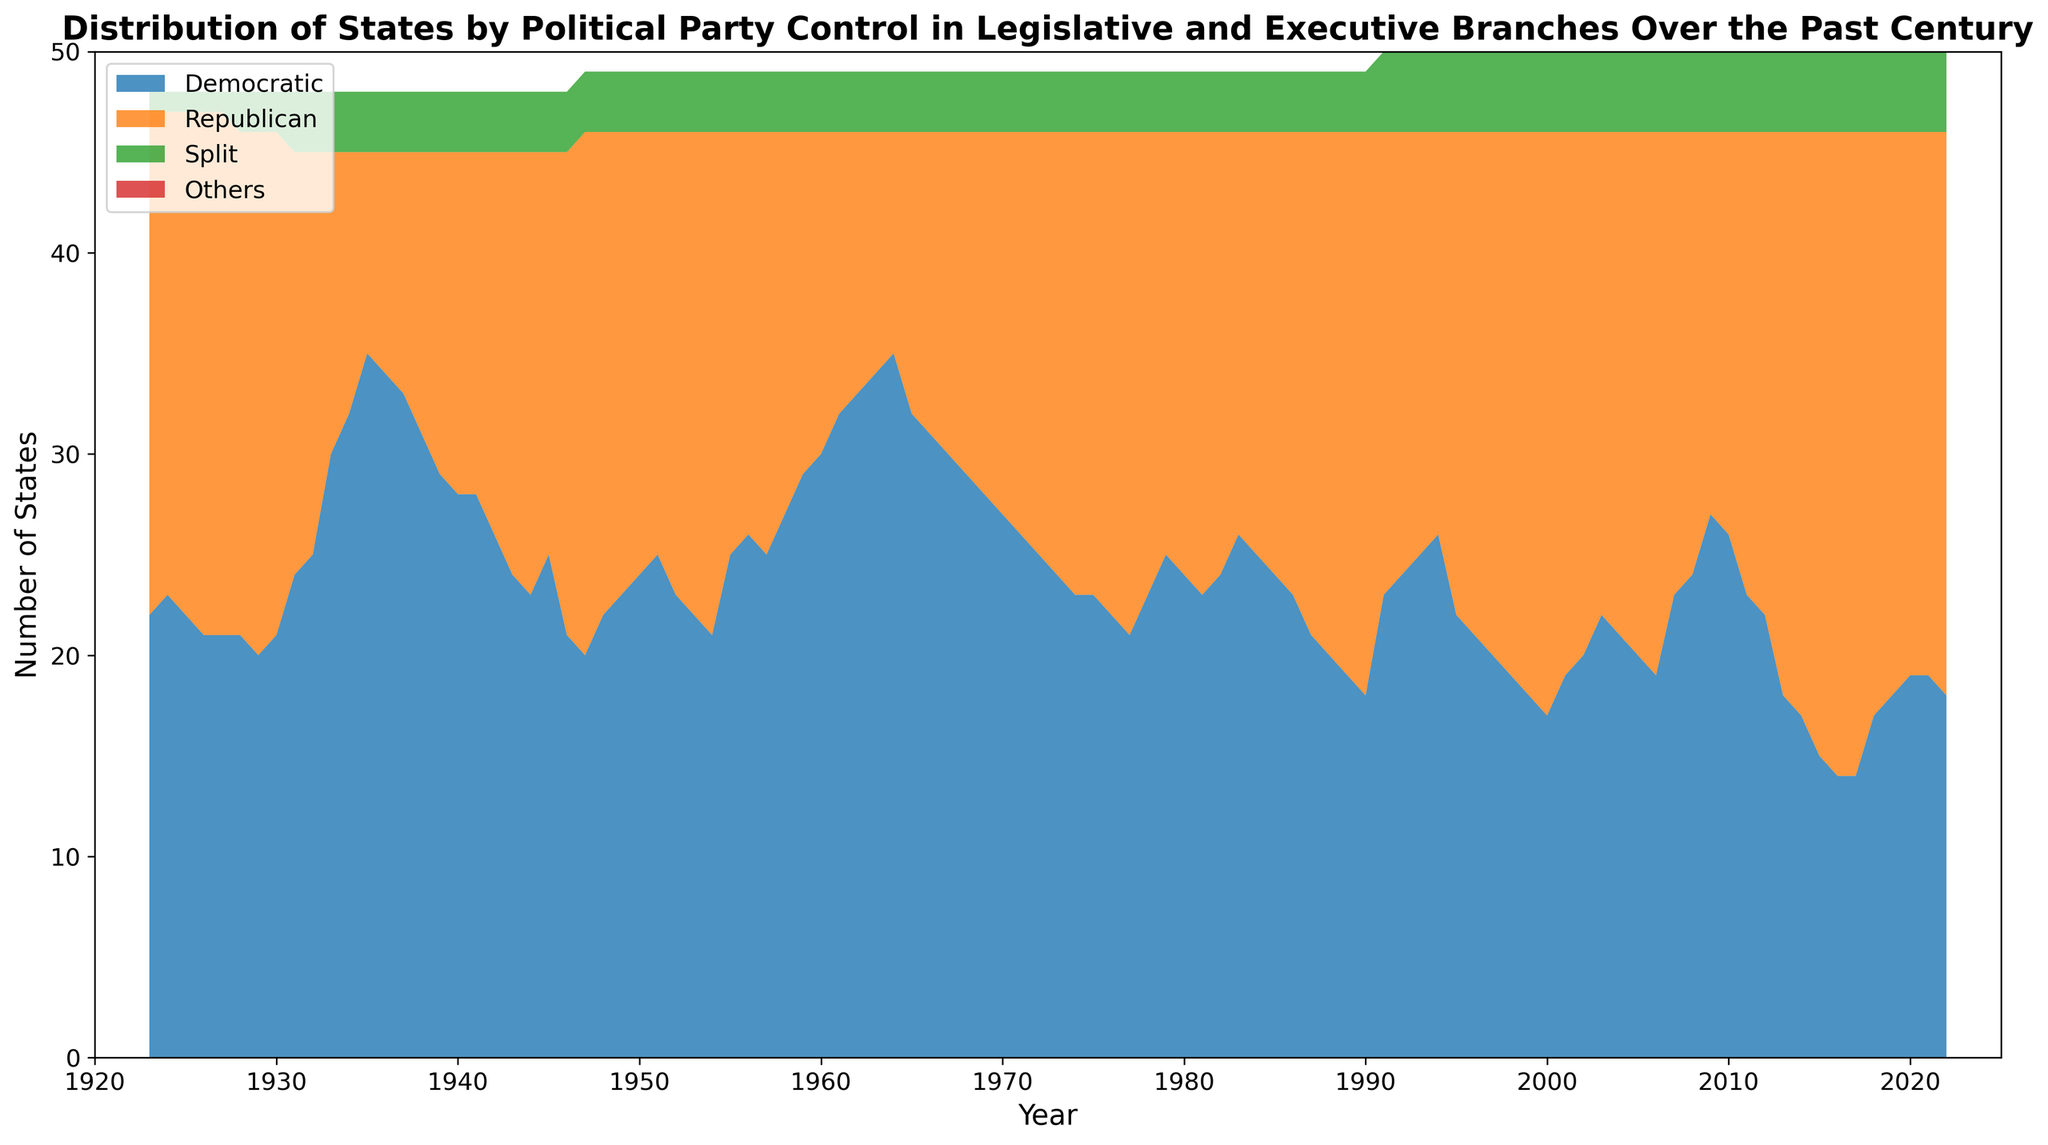What year did the Democratic control of states peak, and how many states were under Democratic control that year? By observing the regions on the chart, the Democratic control seems to have the largest area in the mid-1930s. Specifically, 1935 shows the peak with 35 states under Democratic control.
Answer: 1935, 35 In which decade did the number of states under Republican control generally increase the most? By observing the changing areas of color bands, the Republican control shows a significant increase during the 1990s.
Answer: 1990s Compare the number of states under Democratic control between 1940s and 1980s. By observing and comparing the height of the blue section in each decade, it appears that the Democratic control was generally higher in the 1940s than in the 1980s.
Answer: Higher in the 1940s Which party had control over the majority of states in the year 2000? By observing the stack height for each color in the year 2000, the orange color representing the Republican control is clearly higher than others.
Answer: Republican What was the trend in the number of states with split control over the legislative and executive branches from 1930 to 2020? By following the green section along the timeline, the number of states with split control increased slightly from 3 to 4, showing relative stability over the century.
Answer: Stable, slight increase By how much did Democratic control decrease from 1935 to 1947? The Democratic control decreased from 35 states in 1935 to 20 states in 1947. Subtracting these gives a decrease of 15 states.
Answer: 15 states How does the political control distribution in 2022 compare to that in 1932? Observing both years, 1932 has Democratic (25), Republican (20), Split (3). In 2022, it shows Democratic (18), Republican (28), Split (4). The Democratic control decreased, and the Republican control significantly increased.
Answer: Democratic control decreased, Republican increased What do the color sections represent in the context of this figure? By referring to the legend in the figure, the blue color represents Democratic control, the orange represents Republican control, the green represents Split control, and the red represents Others.
Answer: Democratic (blue), Republican (orange), Split (green), Others (red) During which period did the "Others" category start appearing? By examining the chart, the "Others" category appears consistently as 0 throughout the period, indicating it did not appear at all.
Answer: Did not appear 